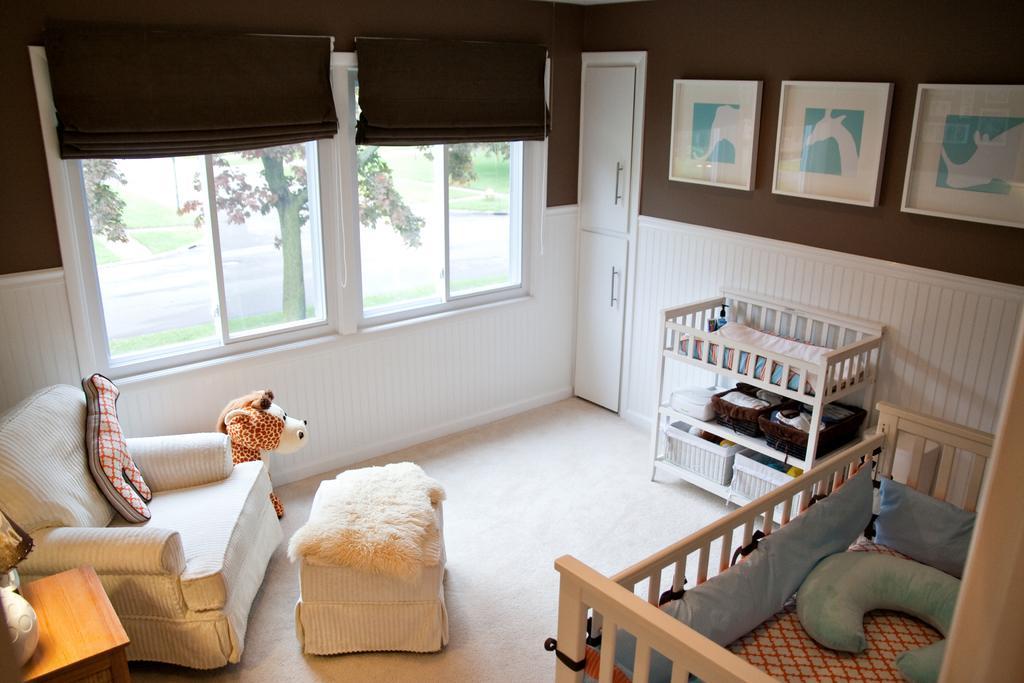Please provide a concise description of this image. This is a picture taken in a room. This is a floor on the floor there are table, chair, toy and on the table there are some items and a baby bed on the bed there are pillows. Behind the bed there is a wall with photos, door and glass windows. 